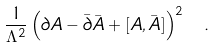Convert formula to latex. <formula><loc_0><loc_0><loc_500><loc_500>\frac { 1 } { \Lambda ^ { 2 } } \left ( \partial A - \bar { \partial } \bar { A } + [ A , \bar { A } ] \right ) ^ { 2 } \ .</formula> 